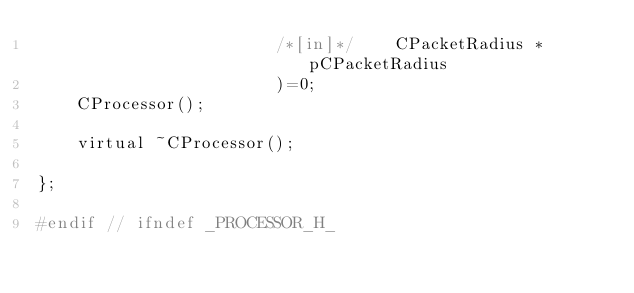<code> <loc_0><loc_0><loc_500><loc_500><_C_>                        /*[in]*/    CPacketRadius *pCPacketRadius
                        )=0;
	CProcessor();

	virtual ~CProcessor();

};

#endif // ifndef _PROCESSOR_H_
</code> 